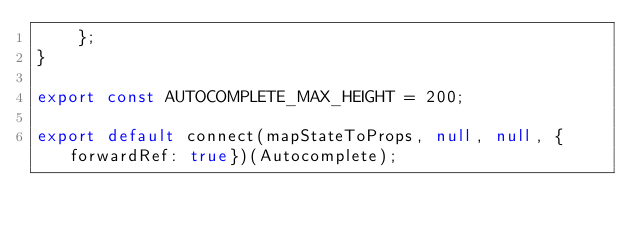Convert code to text. <code><loc_0><loc_0><loc_500><loc_500><_JavaScript_>    };
}

export const AUTOCOMPLETE_MAX_HEIGHT = 200;

export default connect(mapStateToProps, null, null, {forwardRef: true})(Autocomplete);
</code> 